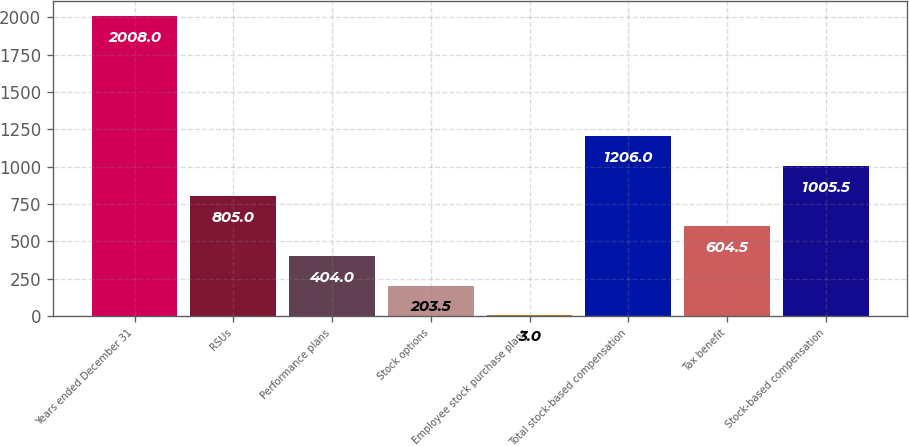Convert chart to OTSL. <chart><loc_0><loc_0><loc_500><loc_500><bar_chart><fcel>Years ended December 31<fcel>RSUs<fcel>Performance plans<fcel>Stock options<fcel>Employee stock purchase plans<fcel>Total stock-based compensation<fcel>Tax benefit<fcel>Stock-based compensation<nl><fcel>2008<fcel>805<fcel>404<fcel>203.5<fcel>3<fcel>1206<fcel>604.5<fcel>1005.5<nl></chart> 